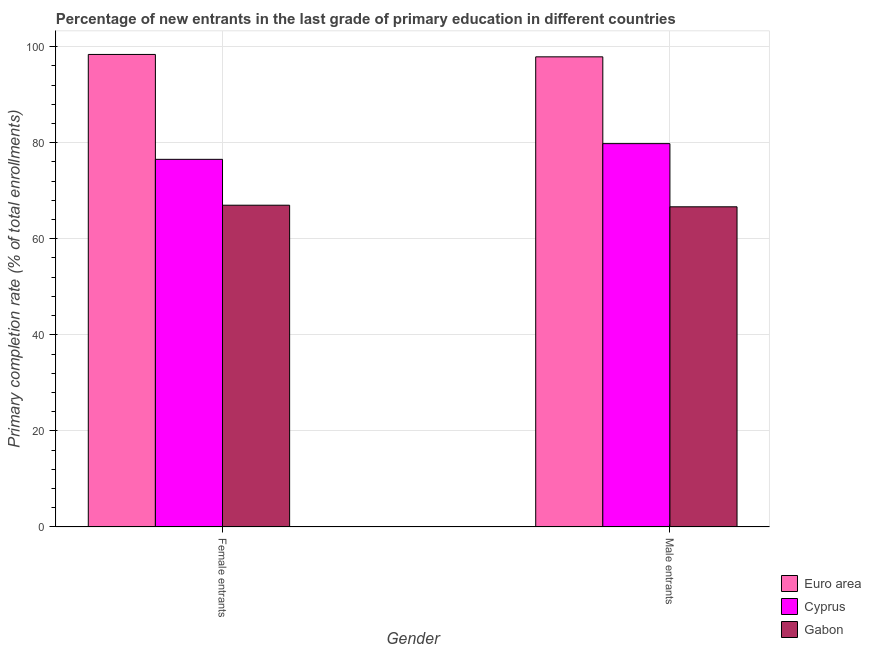How many groups of bars are there?
Provide a short and direct response. 2. What is the label of the 2nd group of bars from the left?
Make the answer very short. Male entrants. What is the primary completion rate of female entrants in Euro area?
Provide a succinct answer. 98.36. Across all countries, what is the maximum primary completion rate of male entrants?
Ensure brevity in your answer.  97.86. Across all countries, what is the minimum primary completion rate of female entrants?
Give a very brief answer. 66.98. In which country was the primary completion rate of male entrants maximum?
Your response must be concise. Euro area. In which country was the primary completion rate of male entrants minimum?
Ensure brevity in your answer.  Gabon. What is the total primary completion rate of male entrants in the graph?
Your answer should be compact. 244.31. What is the difference between the primary completion rate of female entrants in Cyprus and that in Euro area?
Your answer should be very brief. -21.83. What is the difference between the primary completion rate of female entrants in Gabon and the primary completion rate of male entrants in Cyprus?
Offer a very short reply. -12.82. What is the average primary completion rate of male entrants per country?
Provide a succinct answer. 81.44. What is the difference between the primary completion rate of female entrants and primary completion rate of male entrants in Euro area?
Your answer should be very brief. 0.5. In how many countries, is the primary completion rate of male entrants greater than 92 %?
Keep it short and to the point. 1. What is the ratio of the primary completion rate of male entrants in Cyprus to that in Euro area?
Provide a short and direct response. 0.82. Is the primary completion rate of male entrants in Cyprus less than that in Gabon?
Your answer should be compact. No. What does the 1st bar from the left in Female entrants represents?
Provide a short and direct response. Euro area. What does the 3rd bar from the right in Female entrants represents?
Your answer should be very brief. Euro area. How many bars are there?
Your answer should be compact. 6. Are all the bars in the graph horizontal?
Offer a very short reply. No. How many countries are there in the graph?
Your answer should be compact. 3. What is the difference between two consecutive major ticks on the Y-axis?
Your response must be concise. 20. Are the values on the major ticks of Y-axis written in scientific E-notation?
Provide a succinct answer. No. What is the title of the graph?
Your answer should be compact. Percentage of new entrants in the last grade of primary education in different countries. Does "High income" appear as one of the legend labels in the graph?
Keep it short and to the point. No. What is the label or title of the X-axis?
Ensure brevity in your answer.  Gender. What is the label or title of the Y-axis?
Ensure brevity in your answer.  Primary completion rate (% of total enrollments). What is the Primary completion rate (% of total enrollments) in Euro area in Female entrants?
Ensure brevity in your answer.  98.36. What is the Primary completion rate (% of total enrollments) in Cyprus in Female entrants?
Your response must be concise. 76.53. What is the Primary completion rate (% of total enrollments) in Gabon in Female entrants?
Give a very brief answer. 66.98. What is the Primary completion rate (% of total enrollments) of Euro area in Male entrants?
Give a very brief answer. 97.86. What is the Primary completion rate (% of total enrollments) in Cyprus in Male entrants?
Make the answer very short. 79.8. What is the Primary completion rate (% of total enrollments) of Gabon in Male entrants?
Ensure brevity in your answer.  66.65. Across all Gender, what is the maximum Primary completion rate (% of total enrollments) of Euro area?
Keep it short and to the point. 98.36. Across all Gender, what is the maximum Primary completion rate (% of total enrollments) in Cyprus?
Your answer should be compact. 79.8. Across all Gender, what is the maximum Primary completion rate (% of total enrollments) in Gabon?
Your response must be concise. 66.98. Across all Gender, what is the minimum Primary completion rate (% of total enrollments) of Euro area?
Keep it short and to the point. 97.86. Across all Gender, what is the minimum Primary completion rate (% of total enrollments) of Cyprus?
Your answer should be compact. 76.53. Across all Gender, what is the minimum Primary completion rate (% of total enrollments) in Gabon?
Your response must be concise. 66.65. What is the total Primary completion rate (% of total enrollments) in Euro area in the graph?
Make the answer very short. 196.22. What is the total Primary completion rate (% of total enrollments) of Cyprus in the graph?
Offer a very short reply. 156.32. What is the total Primary completion rate (% of total enrollments) in Gabon in the graph?
Provide a short and direct response. 133.63. What is the difference between the Primary completion rate (% of total enrollments) of Euro area in Female entrants and that in Male entrants?
Make the answer very short. 0.5. What is the difference between the Primary completion rate (% of total enrollments) in Cyprus in Female entrants and that in Male entrants?
Your answer should be very brief. -3.27. What is the difference between the Primary completion rate (% of total enrollments) of Gabon in Female entrants and that in Male entrants?
Ensure brevity in your answer.  0.33. What is the difference between the Primary completion rate (% of total enrollments) in Euro area in Female entrants and the Primary completion rate (% of total enrollments) in Cyprus in Male entrants?
Give a very brief answer. 18.56. What is the difference between the Primary completion rate (% of total enrollments) of Euro area in Female entrants and the Primary completion rate (% of total enrollments) of Gabon in Male entrants?
Give a very brief answer. 31.71. What is the difference between the Primary completion rate (% of total enrollments) in Cyprus in Female entrants and the Primary completion rate (% of total enrollments) in Gabon in Male entrants?
Keep it short and to the point. 9.88. What is the average Primary completion rate (% of total enrollments) of Euro area per Gender?
Give a very brief answer. 98.11. What is the average Primary completion rate (% of total enrollments) of Cyprus per Gender?
Keep it short and to the point. 78.16. What is the average Primary completion rate (% of total enrollments) in Gabon per Gender?
Offer a terse response. 66.81. What is the difference between the Primary completion rate (% of total enrollments) of Euro area and Primary completion rate (% of total enrollments) of Cyprus in Female entrants?
Your response must be concise. 21.83. What is the difference between the Primary completion rate (% of total enrollments) in Euro area and Primary completion rate (% of total enrollments) in Gabon in Female entrants?
Make the answer very short. 31.38. What is the difference between the Primary completion rate (% of total enrollments) of Cyprus and Primary completion rate (% of total enrollments) of Gabon in Female entrants?
Provide a short and direct response. 9.55. What is the difference between the Primary completion rate (% of total enrollments) in Euro area and Primary completion rate (% of total enrollments) in Cyprus in Male entrants?
Make the answer very short. 18.07. What is the difference between the Primary completion rate (% of total enrollments) of Euro area and Primary completion rate (% of total enrollments) of Gabon in Male entrants?
Provide a succinct answer. 31.22. What is the difference between the Primary completion rate (% of total enrollments) in Cyprus and Primary completion rate (% of total enrollments) in Gabon in Male entrants?
Your response must be concise. 13.15. What is the difference between the highest and the second highest Primary completion rate (% of total enrollments) of Euro area?
Give a very brief answer. 0.5. What is the difference between the highest and the second highest Primary completion rate (% of total enrollments) of Cyprus?
Keep it short and to the point. 3.27. What is the difference between the highest and the second highest Primary completion rate (% of total enrollments) of Gabon?
Your response must be concise. 0.33. What is the difference between the highest and the lowest Primary completion rate (% of total enrollments) in Euro area?
Your answer should be very brief. 0.5. What is the difference between the highest and the lowest Primary completion rate (% of total enrollments) in Cyprus?
Your response must be concise. 3.27. What is the difference between the highest and the lowest Primary completion rate (% of total enrollments) in Gabon?
Your answer should be compact. 0.33. 